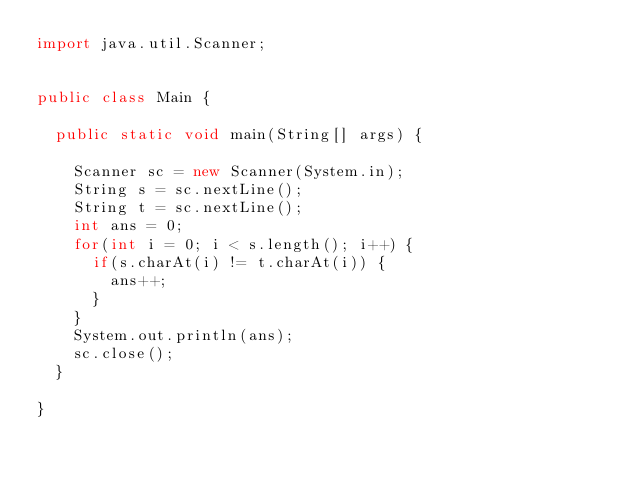Convert code to text. <code><loc_0><loc_0><loc_500><loc_500><_Java_>import java.util.Scanner;


public class Main {

	public static void main(String[] args) {

		Scanner sc = new Scanner(System.in);
		String s = sc.nextLine();
		String t = sc.nextLine();
		int ans = 0;
		for(int i = 0; i < s.length(); i++) {
			if(s.charAt(i) != t.charAt(i)) {
				ans++;
			}
		}
		System.out.println(ans);
		sc.close();
	}

}</code> 